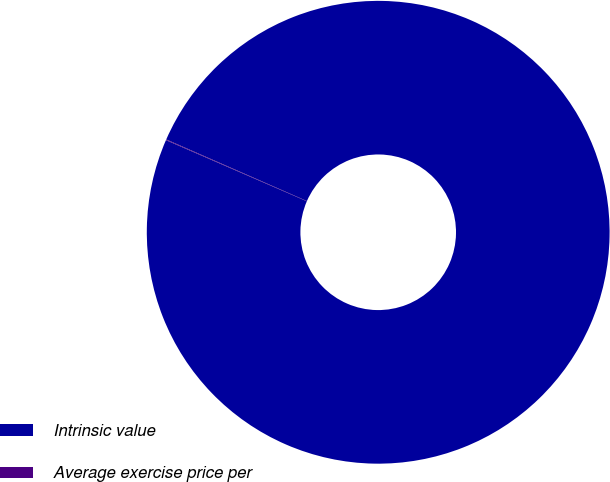<chart> <loc_0><loc_0><loc_500><loc_500><pie_chart><fcel>Intrinsic value<fcel>Average exercise price per<nl><fcel>99.95%<fcel>0.05%<nl></chart> 